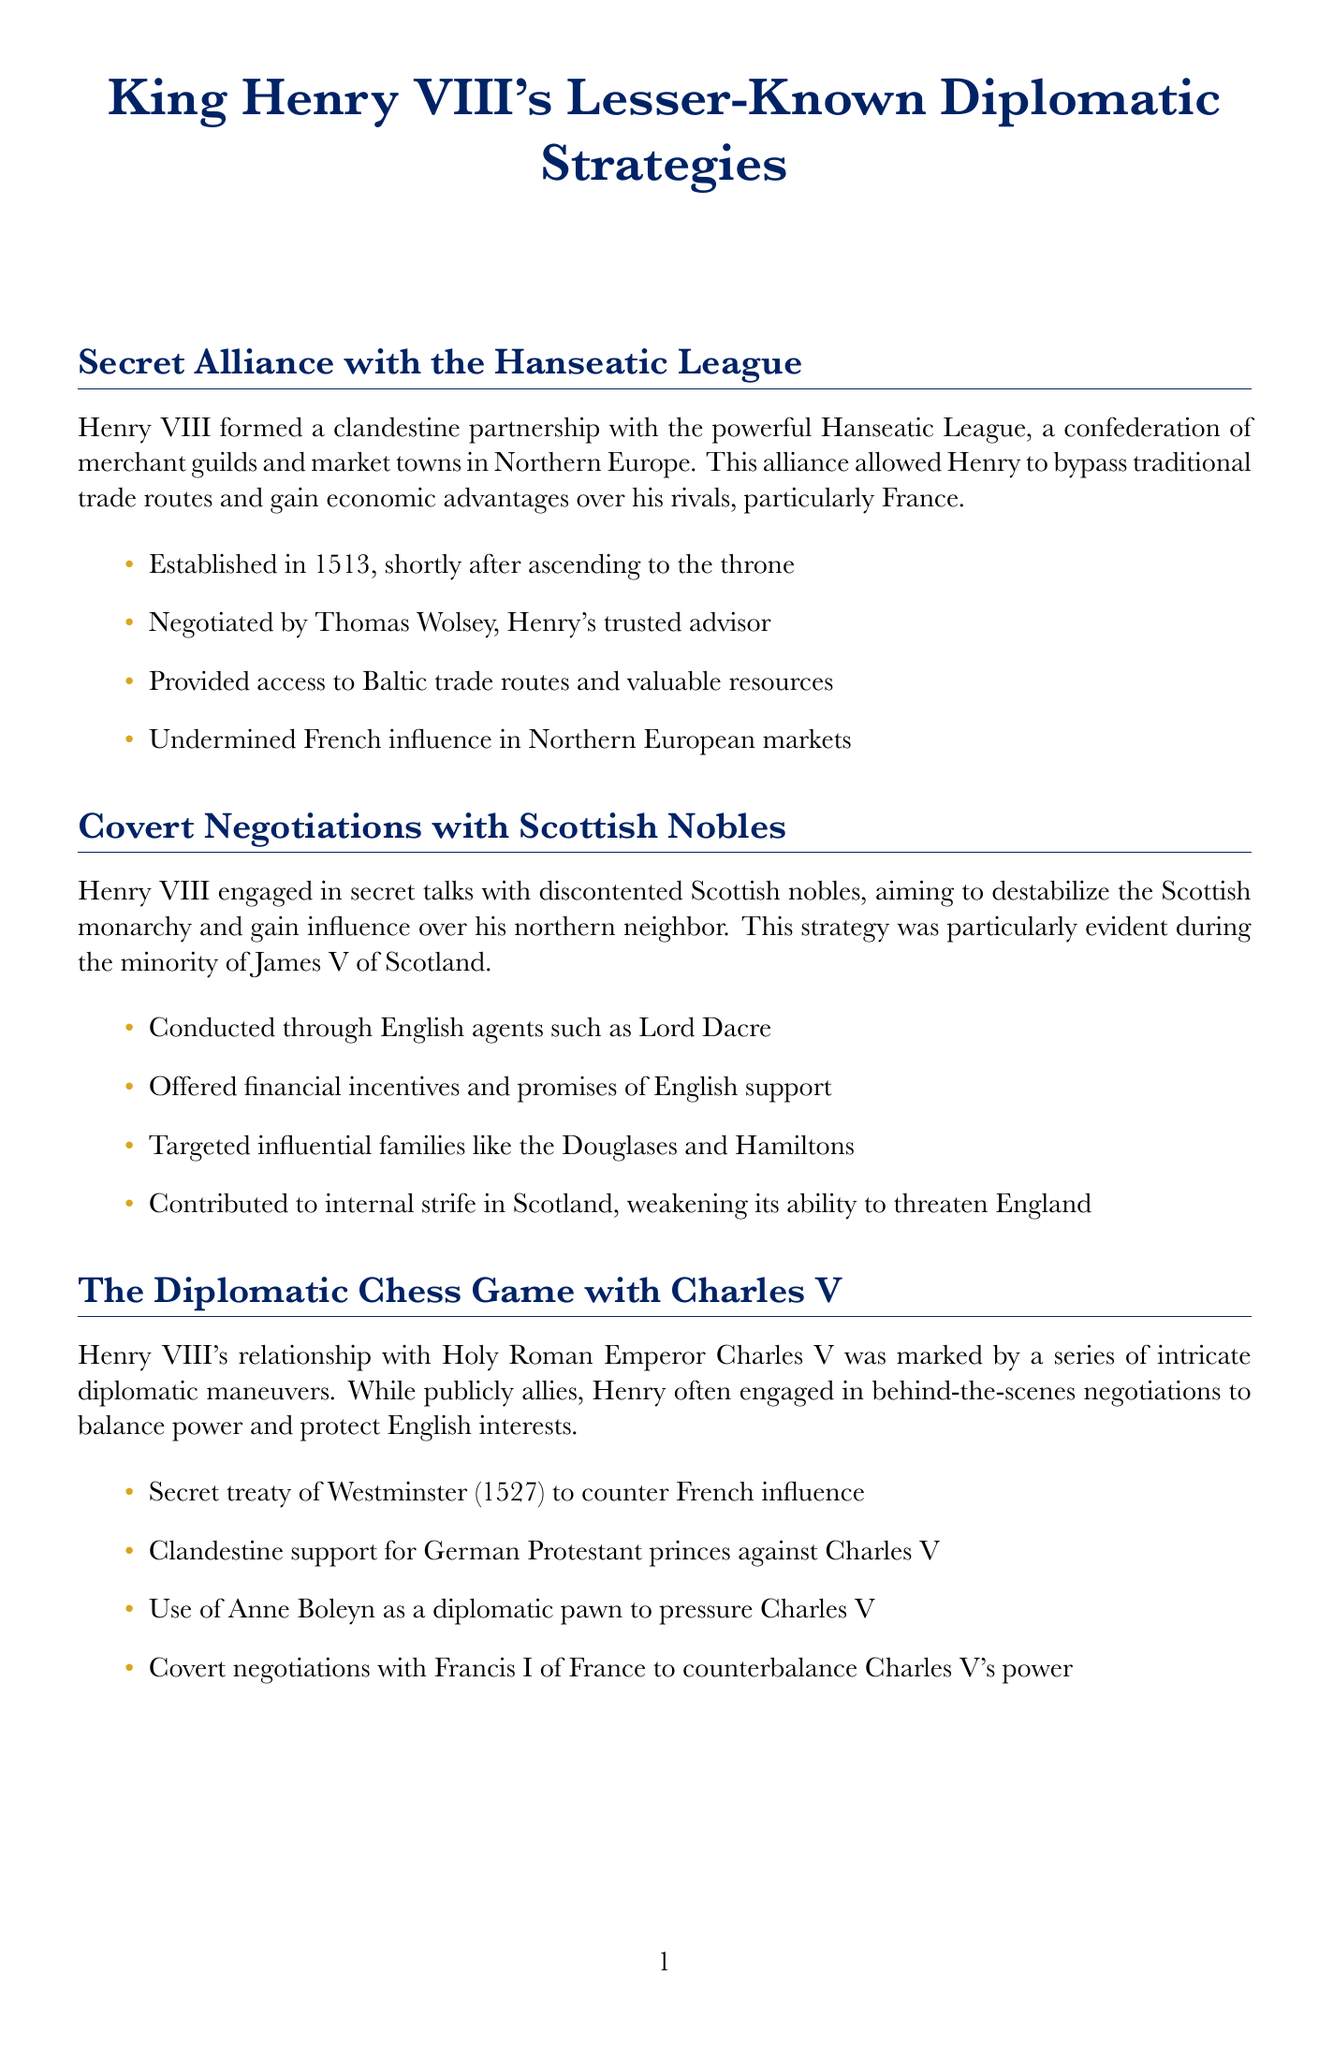what year was the secret alliance with the Hanseatic League established? The document states that the secret alliance was established in 1513, shortly after Henry ascended to the throne.
Answer: 1513 who negotiated the alliance with the Hanseatic League? The negotiation was carried out by Thomas Wolsey, who was Henry's trusted advisor.
Answer: Thomas Wolsey which Scottish nobles did Henry VIII target for his covert negotiations? The document mentions that Henry targeted influential families like the Douglases and Hamiltons during his covert negotiations with Scottish nobles.
Answer: Douglases and Hamiltons what was the secret treaty of Westminster aimed at? The treaty was aimed at countering French influence.
Answer: Counter French influence who was used as a diplomatic pawn to pressure Charles V? According to the document, Anne Boleyn was used as a diplomatic pawn in negotiations with Charles V.
Answer: Anne Boleyn what was the policy introduced in Ireland in 1540? The document states that the policy of 'Surrender and Regrant' was introduced in 1540 as part of Henry's strategy in Ireland.
Answer: Surrender and Regrant which agents were involved in the espionage network? Henry VIII's espionage network was coordinated by Thomas Cromwell and later William Cecil.
Answer: Thomas Cromwell and William Cecil what were Henry’s negotiations with Gaelic chiefs in Ireland intended to achieve? The negotiations were intended to extend English control peacefully in Ireland without full-scale conquest.
Answer: Extend English control what was a significant outcome of Henry’s lesser-known diplomatic strategies? The document suggests that these strategies laid the groundwork for England's emergence as a major European power in the following centuries.
Answer: Emergence as a major European power 